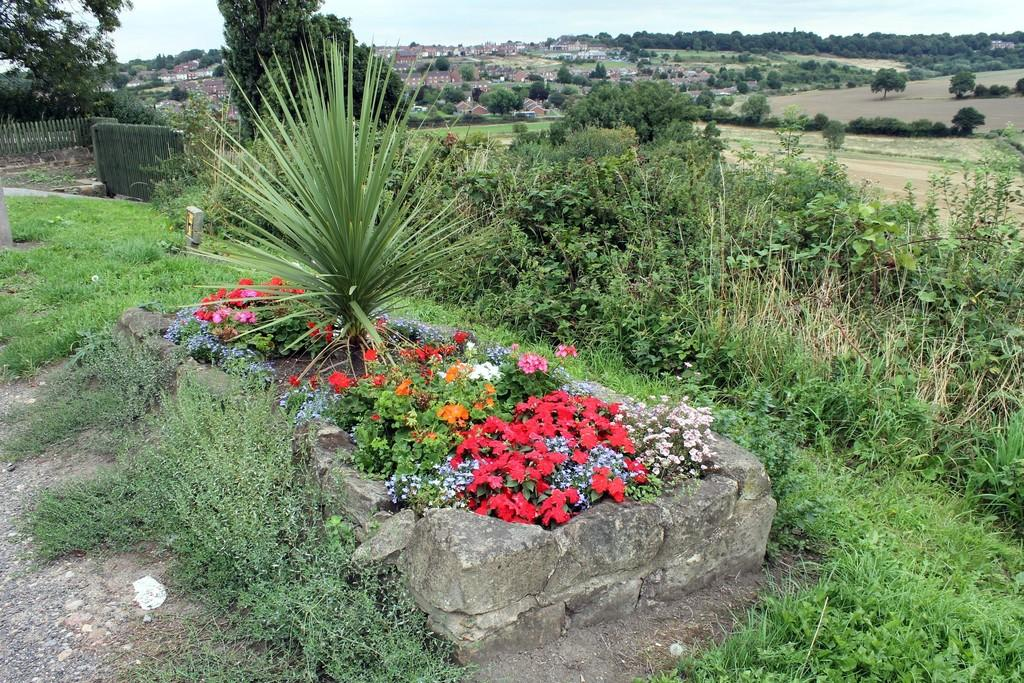What is located in the middle of the image? In the middle of the image, there are plants, flowers, grass, a stone, and land. Can you describe the vegetation in the middle of the image? The vegetation in the middle of the image includes plants, flowers, and grass. What can be seen in the background of the image? In the background of the image, there are trees, houses, crops, a fence, and the sky. What type of punishment is being handed out in the image? There is no indication of punishment in the image; it features plants, flowers, grass, a stone, land, trees, houses, crops, a fence, and the sky. What form does the idea take in the image? There is no idea present in the image; it is a scene of nature and human-made structures. 